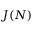<formula> <loc_0><loc_0><loc_500><loc_500>J ( N )</formula> 